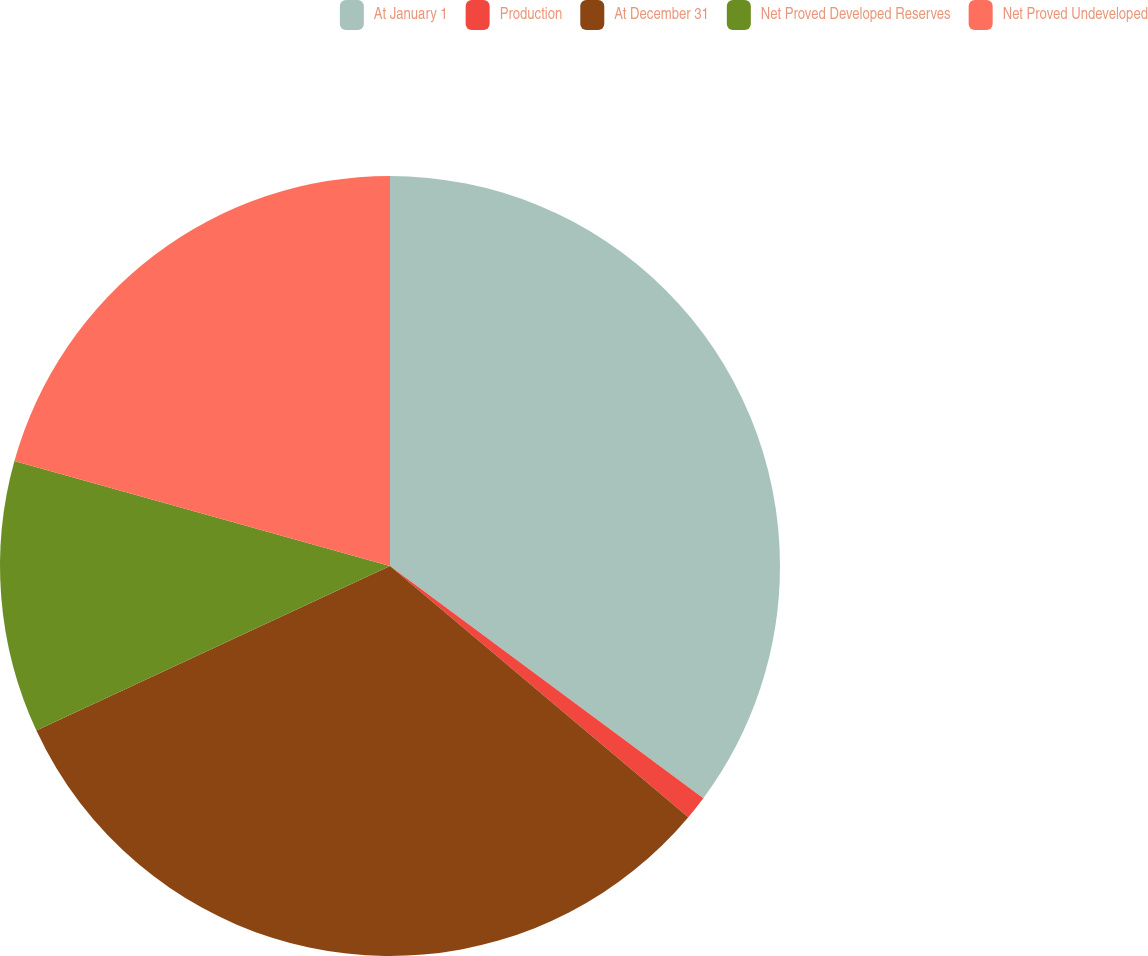Convert chart to OTSL. <chart><loc_0><loc_0><loc_500><loc_500><pie_chart><fcel>At January 1<fcel>Production<fcel>At December 31<fcel>Net Proved Developed Reserves<fcel>Net Proved Undeveloped<nl><fcel>35.15%<fcel>0.99%<fcel>31.93%<fcel>11.27%<fcel>20.66%<nl></chart> 